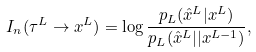Convert formula to latex. <formula><loc_0><loc_0><loc_500><loc_500>I _ { n } ( \tau ^ { L } \rightarrow x ^ { L } ) = \log \frac { p _ { L } ( \hat { x } ^ { L } | x ^ { L } ) } { p _ { L } ( \hat { x } ^ { L } | | x ^ { L - 1 } ) } ,</formula> 